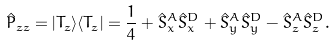Convert formula to latex. <formula><loc_0><loc_0><loc_500><loc_500>\hat { P } _ { z z } = | T _ { z } \rangle \langle T _ { z } | = \frac { 1 } { 4 } + \hat { S } _ { x } ^ { A } \hat { S } _ { x } ^ { D } + \hat { S } _ { y } ^ { A } \hat { S } _ { y } ^ { D } - \hat { S } _ { z } ^ { A } \hat { S } _ { z } ^ { D } .</formula> 